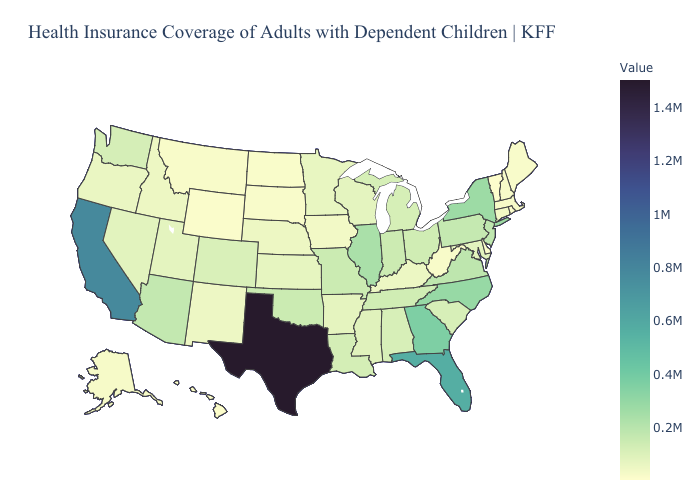Among the states that border Idaho , does Wyoming have the highest value?
Concise answer only. No. Which states hav the highest value in the South?
Short answer required. Texas. Does the map have missing data?
Short answer required. No. Among the states that border Tennessee , which have the lowest value?
Concise answer only. Kentucky. Does the map have missing data?
Write a very short answer. No. Is the legend a continuous bar?
Be succinct. Yes. 